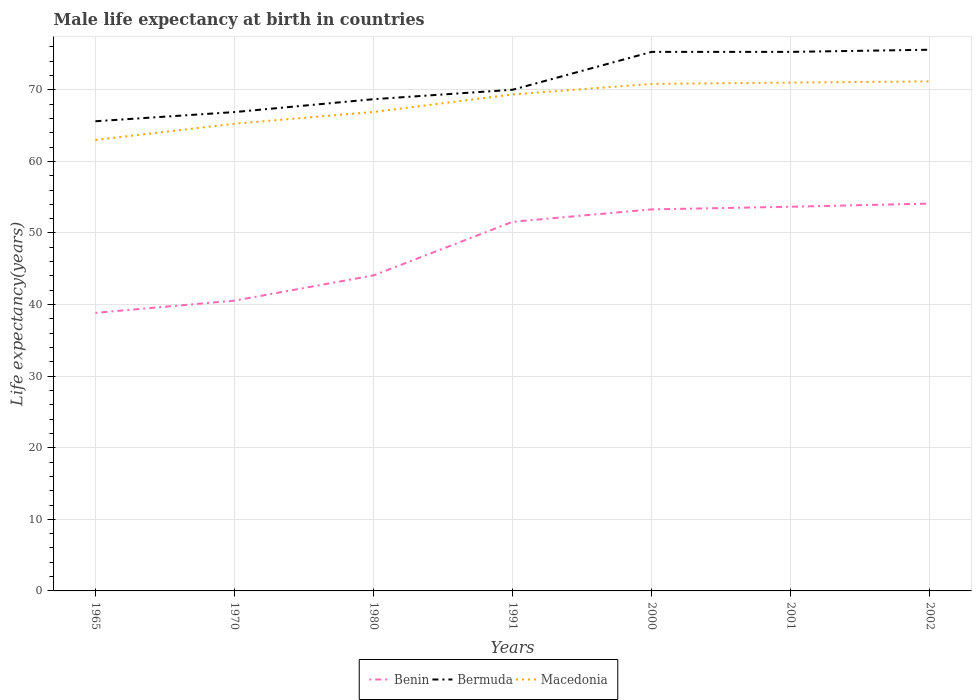How many different coloured lines are there?
Provide a short and direct response. 3. Across all years, what is the maximum male life expectancy at birth in Macedonia?
Your answer should be compact. 63. In which year was the male life expectancy at birth in Macedonia maximum?
Your answer should be compact. 1965. What is the total male life expectancy at birth in Benin in the graph?
Your answer should be compact. -2.1. What is the difference between the highest and the second highest male life expectancy at birth in Macedonia?
Ensure brevity in your answer.  8.18. What is the difference between the highest and the lowest male life expectancy at birth in Benin?
Offer a very short reply. 4. How many lines are there?
Your answer should be very brief. 3. How many years are there in the graph?
Provide a succinct answer. 7. What is the difference between two consecutive major ticks on the Y-axis?
Offer a very short reply. 10. Does the graph contain grids?
Give a very brief answer. Yes. What is the title of the graph?
Provide a succinct answer. Male life expectancy at birth in countries. Does "Zambia" appear as one of the legend labels in the graph?
Your response must be concise. No. What is the label or title of the X-axis?
Offer a terse response. Years. What is the label or title of the Y-axis?
Provide a succinct answer. Life expectancy(years). What is the Life expectancy(years) in Benin in 1965?
Give a very brief answer. 38.84. What is the Life expectancy(years) in Bermuda in 1965?
Provide a succinct answer. 65.61. What is the Life expectancy(years) in Macedonia in 1965?
Keep it short and to the point. 63. What is the Life expectancy(years) in Benin in 1970?
Your answer should be compact. 40.55. What is the Life expectancy(years) of Bermuda in 1970?
Offer a very short reply. 66.89. What is the Life expectancy(years) of Macedonia in 1970?
Offer a very short reply. 65.26. What is the Life expectancy(years) in Benin in 1980?
Your response must be concise. 44.08. What is the Life expectancy(years) of Bermuda in 1980?
Keep it short and to the point. 68.69. What is the Life expectancy(years) of Macedonia in 1980?
Offer a very short reply. 66.91. What is the Life expectancy(years) in Benin in 1991?
Your answer should be compact. 51.56. What is the Life expectancy(years) of Bermuda in 1991?
Your response must be concise. 70.01. What is the Life expectancy(years) in Macedonia in 1991?
Provide a short and direct response. 69.35. What is the Life expectancy(years) of Benin in 2000?
Make the answer very short. 53.3. What is the Life expectancy(years) in Bermuda in 2000?
Provide a short and direct response. 75.3. What is the Life expectancy(years) of Macedonia in 2000?
Provide a short and direct response. 70.83. What is the Life expectancy(years) in Benin in 2001?
Provide a succinct answer. 53.67. What is the Life expectancy(years) of Bermuda in 2001?
Give a very brief answer. 75.3. What is the Life expectancy(years) in Macedonia in 2001?
Give a very brief answer. 71.01. What is the Life expectancy(years) in Benin in 2002?
Your answer should be very brief. 54.11. What is the Life expectancy(years) in Bermuda in 2002?
Offer a very short reply. 75.6. What is the Life expectancy(years) in Macedonia in 2002?
Your answer should be very brief. 71.18. Across all years, what is the maximum Life expectancy(years) of Benin?
Your response must be concise. 54.11. Across all years, what is the maximum Life expectancy(years) of Bermuda?
Provide a succinct answer. 75.6. Across all years, what is the maximum Life expectancy(years) of Macedonia?
Your answer should be very brief. 71.18. Across all years, what is the minimum Life expectancy(years) in Benin?
Provide a succinct answer. 38.84. Across all years, what is the minimum Life expectancy(years) in Bermuda?
Your response must be concise. 65.61. Across all years, what is the minimum Life expectancy(years) of Macedonia?
Offer a very short reply. 63. What is the total Life expectancy(years) in Benin in the graph?
Your response must be concise. 336.11. What is the total Life expectancy(years) of Bermuda in the graph?
Your answer should be compact. 497.4. What is the total Life expectancy(years) of Macedonia in the graph?
Ensure brevity in your answer.  477.54. What is the difference between the Life expectancy(years) of Benin in 1965 and that in 1970?
Offer a terse response. -1.71. What is the difference between the Life expectancy(years) of Bermuda in 1965 and that in 1970?
Your answer should be very brief. -1.28. What is the difference between the Life expectancy(years) in Macedonia in 1965 and that in 1970?
Your response must be concise. -2.26. What is the difference between the Life expectancy(years) of Benin in 1965 and that in 1980?
Your response must be concise. -5.24. What is the difference between the Life expectancy(years) of Bermuda in 1965 and that in 1980?
Provide a succinct answer. -3.08. What is the difference between the Life expectancy(years) in Macedonia in 1965 and that in 1980?
Keep it short and to the point. -3.91. What is the difference between the Life expectancy(years) in Benin in 1965 and that in 1991?
Offer a very short reply. -12.72. What is the difference between the Life expectancy(years) of Macedonia in 1965 and that in 1991?
Provide a succinct answer. -6.35. What is the difference between the Life expectancy(years) of Benin in 1965 and that in 2000?
Make the answer very short. -14.46. What is the difference between the Life expectancy(years) of Bermuda in 1965 and that in 2000?
Provide a succinct answer. -9.69. What is the difference between the Life expectancy(years) in Macedonia in 1965 and that in 2000?
Keep it short and to the point. -7.83. What is the difference between the Life expectancy(years) of Benin in 1965 and that in 2001?
Your answer should be very brief. -14.82. What is the difference between the Life expectancy(years) of Bermuda in 1965 and that in 2001?
Offer a terse response. -9.69. What is the difference between the Life expectancy(years) of Macedonia in 1965 and that in 2001?
Your answer should be compact. -8.01. What is the difference between the Life expectancy(years) of Benin in 1965 and that in 2002?
Make the answer very short. -15.27. What is the difference between the Life expectancy(years) in Bermuda in 1965 and that in 2002?
Ensure brevity in your answer.  -9.99. What is the difference between the Life expectancy(years) of Macedonia in 1965 and that in 2002?
Provide a succinct answer. -8.18. What is the difference between the Life expectancy(years) in Benin in 1970 and that in 1980?
Ensure brevity in your answer.  -3.53. What is the difference between the Life expectancy(years) of Macedonia in 1970 and that in 1980?
Your response must be concise. -1.64. What is the difference between the Life expectancy(years) in Benin in 1970 and that in 1991?
Your answer should be compact. -11.01. What is the difference between the Life expectancy(years) of Bermuda in 1970 and that in 1991?
Make the answer very short. -3.12. What is the difference between the Life expectancy(years) in Macedonia in 1970 and that in 1991?
Give a very brief answer. -4.09. What is the difference between the Life expectancy(years) of Benin in 1970 and that in 2000?
Keep it short and to the point. -12.75. What is the difference between the Life expectancy(years) in Bermuda in 1970 and that in 2000?
Provide a succinct answer. -8.41. What is the difference between the Life expectancy(years) in Macedonia in 1970 and that in 2000?
Give a very brief answer. -5.57. What is the difference between the Life expectancy(years) of Benin in 1970 and that in 2001?
Make the answer very short. -13.12. What is the difference between the Life expectancy(years) in Bermuda in 1970 and that in 2001?
Your answer should be compact. -8.41. What is the difference between the Life expectancy(years) in Macedonia in 1970 and that in 2001?
Ensure brevity in your answer.  -5.74. What is the difference between the Life expectancy(years) of Benin in 1970 and that in 2002?
Keep it short and to the point. -13.56. What is the difference between the Life expectancy(years) of Bermuda in 1970 and that in 2002?
Give a very brief answer. -8.71. What is the difference between the Life expectancy(years) in Macedonia in 1970 and that in 2002?
Give a very brief answer. -5.92. What is the difference between the Life expectancy(years) in Benin in 1980 and that in 1991?
Your response must be concise. -7.49. What is the difference between the Life expectancy(years) of Bermuda in 1980 and that in 1991?
Offer a terse response. -1.32. What is the difference between the Life expectancy(years) of Macedonia in 1980 and that in 1991?
Offer a very short reply. -2.44. What is the difference between the Life expectancy(years) in Benin in 1980 and that in 2000?
Your answer should be compact. -9.22. What is the difference between the Life expectancy(years) of Bermuda in 1980 and that in 2000?
Your answer should be very brief. -6.61. What is the difference between the Life expectancy(years) of Macedonia in 1980 and that in 2000?
Your response must be concise. -3.92. What is the difference between the Life expectancy(years) in Benin in 1980 and that in 2001?
Make the answer very short. -9.59. What is the difference between the Life expectancy(years) of Bermuda in 1980 and that in 2001?
Ensure brevity in your answer.  -6.61. What is the difference between the Life expectancy(years) in Macedonia in 1980 and that in 2001?
Your answer should be compact. -4.1. What is the difference between the Life expectancy(years) in Benin in 1980 and that in 2002?
Ensure brevity in your answer.  -10.03. What is the difference between the Life expectancy(years) in Bermuda in 1980 and that in 2002?
Provide a succinct answer. -6.91. What is the difference between the Life expectancy(years) of Macedonia in 1980 and that in 2002?
Your answer should be very brief. -4.27. What is the difference between the Life expectancy(years) in Benin in 1991 and that in 2000?
Your answer should be very brief. -1.73. What is the difference between the Life expectancy(years) in Bermuda in 1991 and that in 2000?
Offer a terse response. -5.29. What is the difference between the Life expectancy(years) of Macedonia in 1991 and that in 2000?
Your response must be concise. -1.48. What is the difference between the Life expectancy(years) in Benin in 1991 and that in 2001?
Make the answer very short. -2.1. What is the difference between the Life expectancy(years) in Bermuda in 1991 and that in 2001?
Offer a very short reply. -5.29. What is the difference between the Life expectancy(years) of Macedonia in 1991 and that in 2001?
Give a very brief answer. -1.65. What is the difference between the Life expectancy(years) of Benin in 1991 and that in 2002?
Keep it short and to the point. -2.54. What is the difference between the Life expectancy(years) of Bermuda in 1991 and that in 2002?
Your answer should be very brief. -5.59. What is the difference between the Life expectancy(years) in Macedonia in 1991 and that in 2002?
Offer a very short reply. -1.83. What is the difference between the Life expectancy(years) of Benin in 2000 and that in 2001?
Offer a very short reply. -0.37. What is the difference between the Life expectancy(years) in Bermuda in 2000 and that in 2001?
Your answer should be compact. 0. What is the difference between the Life expectancy(years) of Macedonia in 2000 and that in 2001?
Keep it short and to the point. -0.18. What is the difference between the Life expectancy(years) of Benin in 2000 and that in 2002?
Provide a succinct answer. -0.81. What is the difference between the Life expectancy(years) in Bermuda in 2000 and that in 2002?
Ensure brevity in your answer.  -0.3. What is the difference between the Life expectancy(years) of Macedonia in 2000 and that in 2002?
Your response must be concise. -0.35. What is the difference between the Life expectancy(years) in Benin in 2001 and that in 2002?
Provide a succinct answer. -0.44. What is the difference between the Life expectancy(years) of Bermuda in 2001 and that in 2002?
Provide a succinct answer. -0.3. What is the difference between the Life expectancy(years) of Macedonia in 2001 and that in 2002?
Ensure brevity in your answer.  -0.17. What is the difference between the Life expectancy(years) of Benin in 1965 and the Life expectancy(years) of Bermuda in 1970?
Your answer should be compact. -28.05. What is the difference between the Life expectancy(years) in Benin in 1965 and the Life expectancy(years) in Macedonia in 1970?
Your answer should be compact. -26.42. What is the difference between the Life expectancy(years) of Bermuda in 1965 and the Life expectancy(years) of Macedonia in 1970?
Your answer should be very brief. 0.35. What is the difference between the Life expectancy(years) in Benin in 1965 and the Life expectancy(years) in Bermuda in 1980?
Offer a very short reply. -29.85. What is the difference between the Life expectancy(years) in Benin in 1965 and the Life expectancy(years) in Macedonia in 1980?
Provide a succinct answer. -28.07. What is the difference between the Life expectancy(years) in Bermuda in 1965 and the Life expectancy(years) in Macedonia in 1980?
Your answer should be compact. -1.3. What is the difference between the Life expectancy(years) in Benin in 1965 and the Life expectancy(years) in Bermuda in 1991?
Your answer should be compact. -31.17. What is the difference between the Life expectancy(years) in Benin in 1965 and the Life expectancy(years) in Macedonia in 1991?
Offer a terse response. -30.51. What is the difference between the Life expectancy(years) of Bermuda in 1965 and the Life expectancy(years) of Macedonia in 1991?
Offer a very short reply. -3.74. What is the difference between the Life expectancy(years) of Benin in 1965 and the Life expectancy(years) of Bermuda in 2000?
Offer a very short reply. -36.46. What is the difference between the Life expectancy(years) of Benin in 1965 and the Life expectancy(years) of Macedonia in 2000?
Offer a very short reply. -31.99. What is the difference between the Life expectancy(years) in Bermuda in 1965 and the Life expectancy(years) in Macedonia in 2000?
Your response must be concise. -5.22. What is the difference between the Life expectancy(years) in Benin in 1965 and the Life expectancy(years) in Bermuda in 2001?
Ensure brevity in your answer.  -36.46. What is the difference between the Life expectancy(years) in Benin in 1965 and the Life expectancy(years) in Macedonia in 2001?
Provide a short and direct response. -32.16. What is the difference between the Life expectancy(years) in Bermuda in 1965 and the Life expectancy(years) in Macedonia in 2001?
Make the answer very short. -5.4. What is the difference between the Life expectancy(years) in Benin in 1965 and the Life expectancy(years) in Bermuda in 2002?
Offer a terse response. -36.76. What is the difference between the Life expectancy(years) of Benin in 1965 and the Life expectancy(years) of Macedonia in 2002?
Provide a short and direct response. -32.34. What is the difference between the Life expectancy(years) of Bermuda in 1965 and the Life expectancy(years) of Macedonia in 2002?
Your response must be concise. -5.57. What is the difference between the Life expectancy(years) in Benin in 1970 and the Life expectancy(years) in Bermuda in 1980?
Your response must be concise. -28.14. What is the difference between the Life expectancy(years) of Benin in 1970 and the Life expectancy(years) of Macedonia in 1980?
Your response must be concise. -26.36. What is the difference between the Life expectancy(years) in Bermuda in 1970 and the Life expectancy(years) in Macedonia in 1980?
Provide a short and direct response. -0.02. What is the difference between the Life expectancy(years) of Benin in 1970 and the Life expectancy(years) of Bermuda in 1991?
Offer a very short reply. -29.46. What is the difference between the Life expectancy(years) in Benin in 1970 and the Life expectancy(years) in Macedonia in 1991?
Your answer should be compact. -28.8. What is the difference between the Life expectancy(years) in Bermuda in 1970 and the Life expectancy(years) in Macedonia in 1991?
Provide a succinct answer. -2.46. What is the difference between the Life expectancy(years) of Benin in 1970 and the Life expectancy(years) of Bermuda in 2000?
Offer a very short reply. -34.75. What is the difference between the Life expectancy(years) in Benin in 1970 and the Life expectancy(years) in Macedonia in 2000?
Keep it short and to the point. -30.28. What is the difference between the Life expectancy(years) of Bermuda in 1970 and the Life expectancy(years) of Macedonia in 2000?
Give a very brief answer. -3.94. What is the difference between the Life expectancy(years) of Benin in 1970 and the Life expectancy(years) of Bermuda in 2001?
Provide a short and direct response. -34.75. What is the difference between the Life expectancy(years) of Benin in 1970 and the Life expectancy(years) of Macedonia in 2001?
Provide a succinct answer. -30.46. What is the difference between the Life expectancy(years) in Bermuda in 1970 and the Life expectancy(years) in Macedonia in 2001?
Provide a short and direct response. -4.12. What is the difference between the Life expectancy(years) of Benin in 1970 and the Life expectancy(years) of Bermuda in 2002?
Your answer should be compact. -35.05. What is the difference between the Life expectancy(years) of Benin in 1970 and the Life expectancy(years) of Macedonia in 2002?
Keep it short and to the point. -30.63. What is the difference between the Life expectancy(years) in Bermuda in 1970 and the Life expectancy(years) in Macedonia in 2002?
Your response must be concise. -4.29. What is the difference between the Life expectancy(years) in Benin in 1980 and the Life expectancy(years) in Bermuda in 1991?
Your answer should be very brief. -25.93. What is the difference between the Life expectancy(years) of Benin in 1980 and the Life expectancy(years) of Macedonia in 1991?
Offer a very short reply. -25.27. What is the difference between the Life expectancy(years) of Bermuda in 1980 and the Life expectancy(years) of Macedonia in 1991?
Provide a short and direct response. -0.66. What is the difference between the Life expectancy(years) in Benin in 1980 and the Life expectancy(years) in Bermuda in 2000?
Your answer should be very brief. -31.22. What is the difference between the Life expectancy(years) in Benin in 1980 and the Life expectancy(years) in Macedonia in 2000?
Provide a succinct answer. -26.75. What is the difference between the Life expectancy(years) of Bermuda in 1980 and the Life expectancy(years) of Macedonia in 2000?
Your answer should be very brief. -2.14. What is the difference between the Life expectancy(years) of Benin in 1980 and the Life expectancy(years) of Bermuda in 2001?
Provide a short and direct response. -31.22. What is the difference between the Life expectancy(years) of Benin in 1980 and the Life expectancy(years) of Macedonia in 2001?
Give a very brief answer. -26.93. What is the difference between the Life expectancy(years) of Bermuda in 1980 and the Life expectancy(years) of Macedonia in 2001?
Ensure brevity in your answer.  -2.32. What is the difference between the Life expectancy(years) in Benin in 1980 and the Life expectancy(years) in Bermuda in 2002?
Give a very brief answer. -31.52. What is the difference between the Life expectancy(years) of Benin in 1980 and the Life expectancy(years) of Macedonia in 2002?
Ensure brevity in your answer.  -27.1. What is the difference between the Life expectancy(years) of Bermuda in 1980 and the Life expectancy(years) of Macedonia in 2002?
Your answer should be compact. -2.49. What is the difference between the Life expectancy(years) of Benin in 1991 and the Life expectancy(years) of Bermuda in 2000?
Ensure brevity in your answer.  -23.74. What is the difference between the Life expectancy(years) in Benin in 1991 and the Life expectancy(years) in Macedonia in 2000?
Make the answer very short. -19.27. What is the difference between the Life expectancy(years) in Bermuda in 1991 and the Life expectancy(years) in Macedonia in 2000?
Make the answer very short. -0.82. What is the difference between the Life expectancy(years) of Benin in 1991 and the Life expectancy(years) of Bermuda in 2001?
Make the answer very short. -23.74. What is the difference between the Life expectancy(years) in Benin in 1991 and the Life expectancy(years) in Macedonia in 2001?
Ensure brevity in your answer.  -19.44. What is the difference between the Life expectancy(years) of Bermuda in 1991 and the Life expectancy(years) of Macedonia in 2001?
Give a very brief answer. -1. What is the difference between the Life expectancy(years) in Benin in 1991 and the Life expectancy(years) in Bermuda in 2002?
Your response must be concise. -24.04. What is the difference between the Life expectancy(years) in Benin in 1991 and the Life expectancy(years) in Macedonia in 2002?
Offer a terse response. -19.62. What is the difference between the Life expectancy(years) of Bermuda in 1991 and the Life expectancy(years) of Macedonia in 2002?
Give a very brief answer. -1.17. What is the difference between the Life expectancy(years) in Benin in 2000 and the Life expectancy(years) in Bermuda in 2001?
Provide a succinct answer. -22. What is the difference between the Life expectancy(years) in Benin in 2000 and the Life expectancy(years) in Macedonia in 2001?
Keep it short and to the point. -17.71. What is the difference between the Life expectancy(years) in Bermuda in 2000 and the Life expectancy(years) in Macedonia in 2001?
Offer a terse response. 4.29. What is the difference between the Life expectancy(years) of Benin in 2000 and the Life expectancy(years) of Bermuda in 2002?
Your answer should be compact. -22.3. What is the difference between the Life expectancy(years) of Benin in 2000 and the Life expectancy(years) of Macedonia in 2002?
Your answer should be very brief. -17.88. What is the difference between the Life expectancy(years) of Bermuda in 2000 and the Life expectancy(years) of Macedonia in 2002?
Your response must be concise. 4.12. What is the difference between the Life expectancy(years) in Benin in 2001 and the Life expectancy(years) in Bermuda in 2002?
Your response must be concise. -21.93. What is the difference between the Life expectancy(years) of Benin in 2001 and the Life expectancy(years) of Macedonia in 2002?
Offer a very short reply. -17.52. What is the difference between the Life expectancy(years) in Bermuda in 2001 and the Life expectancy(years) in Macedonia in 2002?
Your answer should be compact. 4.12. What is the average Life expectancy(years) in Benin per year?
Provide a succinct answer. 48.02. What is the average Life expectancy(years) of Bermuda per year?
Provide a short and direct response. 71.06. What is the average Life expectancy(years) of Macedonia per year?
Ensure brevity in your answer.  68.22. In the year 1965, what is the difference between the Life expectancy(years) in Benin and Life expectancy(years) in Bermuda?
Your response must be concise. -26.77. In the year 1965, what is the difference between the Life expectancy(years) in Benin and Life expectancy(years) in Macedonia?
Provide a succinct answer. -24.16. In the year 1965, what is the difference between the Life expectancy(years) of Bermuda and Life expectancy(years) of Macedonia?
Keep it short and to the point. 2.61. In the year 1970, what is the difference between the Life expectancy(years) of Benin and Life expectancy(years) of Bermuda?
Make the answer very short. -26.34. In the year 1970, what is the difference between the Life expectancy(years) of Benin and Life expectancy(years) of Macedonia?
Your answer should be compact. -24.71. In the year 1970, what is the difference between the Life expectancy(years) of Bermuda and Life expectancy(years) of Macedonia?
Offer a terse response. 1.63. In the year 1980, what is the difference between the Life expectancy(years) in Benin and Life expectancy(years) in Bermuda?
Keep it short and to the point. -24.61. In the year 1980, what is the difference between the Life expectancy(years) of Benin and Life expectancy(years) of Macedonia?
Your answer should be compact. -22.83. In the year 1980, what is the difference between the Life expectancy(years) in Bermuda and Life expectancy(years) in Macedonia?
Offer a terse response. 1.78. In the year 1991, what is the difference between the Life expectancy(years) in Benin and Life expectancy(years) in Bermuda?
Keep it short and to the point. -18.45. In the year 1991, what is the difference between the Life expectancy(years) of Benin and Life expectancy(years) of Macedonia?
Give a very brief answer. -17.79. In the year 1991, what is the difference between the Life expectancy(years) of Bermuda and Life expectancy(years) of Macedonia?
Ensure brevity in your answer.  0.66. In the year 2000, what is the difference between the Life expectancy(years) in Benin and Life expectancy(years) in Bermuda?
Your answer should be very brief. -22. In the year 2000, what is the difference between the Life expectancy(years) of Benin and Life expectancy(years) of Macedonia?
Give a very brief answer. -17.53. In the year 2000, what is the difference between the Life expectancy(years) in Bermuda and Life expectancy(years) in Macedonia?
Your answer should be very brief. 4.47. In the year 2001, what is the difference between the Life expectancy(years) in Benin and Life expectancy(years) in Bermuda?
Your response must be concise. -21.63. In the year 2001, what is the difference between the Life expectancy(years) in Benin and Life expectancy(years) in Macedonia?
Give a very brief answer. -17.34. In the year 2001, what is the difference between the Life expectancy(years) in Bermuda and Life expectancy(years) in Macedonia?
Provide a succinct answer. 4.29. In the year 2002, what is the difference between the Life expectancy(years) in Benin and Life expectancy(years) in Bermuda?
Provide a short and direct response. -21.49. In the year 2002, what is the difference between the Life expectancy(years) of Benin and Life expectancy(years) of Macedonia?
Your response must be concise. -17.07. In the year 2002, what is the difference between the Life expectancy(years) in Bermuda and Life expectancy(years) in Macedonia?
Provide a short and direct response. 4.42. What is the ratio of the Life expectancy(years) in Benin in 1965 to that in 1970?
Provide a short and direct response. 0.96. What is the ratio of the Life expectancy(years) in Bermuda in 1965 to that in 1970?
Your response must be concise. 0.98. What is the ratio of the Life expectancy(years) of Macedonia in 1965 to that in 1970?
Make the answer very short. 0.97. What is the ratio of the Life expectancy(years) of Benin in 1965 to that in 1980?
Ensure brevity in your answer.  0.88. What is the ratio of the Life expectancy(years) in Bermuda in 1965 to that in 1980?
Provide a succinct answer. 0.96. What is the ratio of the Life expectancy(years) in Macedonia in 1965 to that in 1980?
Ensure brevity in your answer.  0.94. What is the ratio of the Life expectancy(years) in Benin in 1965 to that in 1991?
Give a very brief answer. 0.75. What is the ratio of the Life expectancy(years) of Bermuda in 1965 to that in 1991?
Your answer should be very brief. 0.94. What is the ratio of the Life expectancy(years) of Macedonia in 1965 to that in 1991?
Give a very brief answer. 0.91. What is the ratio of the Life expectancy(years) of Benin in 1965 to that in 2000?
Give a very brief answer. 0.73. What is the ratio of the Life expectancy(years) of Bermuda in 1965 to that in 2000?
Your response must be concise. 0.87. What is the ratio of the Life expectancy(years) of Macedonia in 1965 to that in 2000?
Your answer should be compact. 0.89. What is the ratio of the Life expectancy(years) in Benin in 1965 to that in 2001?
Ensure brevity in your answer.  0.72. What is the ratio of the Life expectancy(years) of Bermuda in 1965 to that in 2001?
Ensure brevity in your answer.  0.87. What is the ratio of the Life expectancy(years) in Macedonia in 1965 to that in 2001?
Provide a succinct answer. 0.89. What is the ratio of the Life expectancy(years) in Benin in 1965 to that in 2002?
Ensure brevity in your answer.  0.72. What is the ratio of the Life expectancy(years) of Bermuda in 1965 to that in 2002?
Ensure brevity in your answer.  0.87. What is the ratio of the Life expectancy(years) in Macedonia in 1965 to that in 2002?
Provide a succinct answer. 0.89. What is the ratio of the Life expectancy(years) of Bermuda in 1970 to that in 1980?
Your answer should be very brief. 0.97. What is the ratio of the Life expectancy(years) in Macedonia in 1970 to that in 1980?
Provide a short and direct response. 0.98. What is the ratio of the Life expectancy(years) in Benin in 1970 to that in 1991?
Give a very brief answer. 0.79. What is the ratio of the Life expectancy(years) in Bermuda in 1970 to that in 1991?
Offer a very short reply. 0.96. What is the ratio of the Life expectancy(years) in Macedonia in 1970 to that in 1991?
Your answer should be very brief. 0.94. What is the ratio of the Life expectancy(years) in Benin in 1970 to that in 2000?
Provide a succinct answer. 0.76. What is the ratio of the Life expectancy(years) of Bermuda in 1970 to that in 2000?
Give a very brief answer. 0.89. What is the ratio of the Life expectancy(years) of Macedonia in 1970 to that in 2000?
Provide a short and direct response. 0.92. What is the ratio of the Life expectancy(years) in Benin in 1970 to that in 2001?
Provide a succinct answer. 0.76. What is the ratio of the Life expectancy(years) in Bermuda in 1970 to that in 2001?
Keep it short and to the point. 0.89. What is the ratio of the Life expectancy(years) in Macedonia in 1970 to that in 2001?
Give a very brief answer. 0.92. What is the ratio of the Life expectancy(years) in Benin in 1970 to that in 2002?
Keep it short and to the point. 0.75. What is the ratio of the Life expectancy(years) of Bermuda in 1970 to that in 2002?
Your response must be concise. 0.88. What is the ratio of the Life expectancy(years) in Macedonia in 1970 to that in 2002?
Provide a succinct answer. 0.92. What is the ratio of the Life expectancy(years) in Benin in 1980 to that in 1991?
Keep it short and to the point. 0.85. What is the ratio of the Life expectancy(years) in Bermuda in 1980 to that in 1991?
Provide a short and direct response. 0.98. What is the ratio of the Life expectancy(years) of Macedonia in 1980 to that in 1991?
Provide a succinct answer. 0.96. What is the ratio of the Life expectancy(years) in Benin in 1980 to that in 2000?
Offer a terse response. 0.83. What is the ratio of the Life expectancy(years) of Bermuda in 1980 to that in 2000?
Your answer should be very brief. 0.91. What is the ratio of the Life expectancy(years) of Macedonia in 1980 to that in 2000?
Your answer should be compact. 0.94. What is the ratio of the Life expectancy(years) in Benin in 1980 to that in 2001?
Provide a short and direct response. 0.82. What is the ratio of the Life expectancy(years) in Bermuda in 1980 to that in 2001?
Make the answer very short. 0.91. What is the ratio of the Life expectancy(years) of Macedonia in 1980 to that in 2001?
Your response must be concise. 0.94. What is the ratio of the Life expectancy(years) in Benin in 1980 to that in 2002?
Your answer should be compact. 0.81. What is the ratio of the Life expectancy(years) in Bermuda in 1980 to that in 2002?
Provide a short and direct response. 0.91. What is the ratio of the Life expectancy(years) in Macedonia in 1980 to that in 2002?
Make the answer very short. 0.94. What is the ratio of the Life expectancy(years) in Benin in 1991 to that in 2000?
Offer a very short reply. 0.97. What is the ratio of the Life expectancy(years) in Bermuda in 1991 to that in 2000?
Ensure brevity in your answer.  0.93. What is the ratio of the Life expectancy(years) of Macedonia in 1991 to that in 2000?
Keep it short and to the point. 0.98. What is the ratio of the Life expectancy(years) in Benin in 1991 to that in 2001?
Your answer should be very brief. 0.96. What is the ratio of the Life expectancy(years) of Bermuda in 1991 to that in 2001?
Your response must be concise. 0.93. What is the ratio of the Life expectancy(years) of Macedonia in 1991 to that in 2001?
Ensure brevity in your answer.  0.98. What is the ratio of the Life expectancy(years) of Benin in 1991 to that in 2002?
Ensure brevity in your answer.  0.95. What is the ratio of the Life expectancy(years) in Bermuda in 1991 to that in 2002?
Your answer should be compact. 0.93. What is the ratio of the Life expectancy(years) in Macedonia in 1991 to that in 2002?
Ensure brevity in your answer.  0.97. What is the ratio of the Life expectancy(years) in Macedonia in 2000 to that in 2001?
Make the answer very short. 1. What is the ratio of the Life expectancy(years) of Benin in 2000 to that in 2002?
Your answer should be compact. 0.98. What is the ratio of the Life expectancy(years) of Bermuda in 2000 to that in 2002?
Keep it short and to the point. 1. What is the ratio of the Life expectancy(years) of Macedonia in 2000 to that in 2002?
Ensure brevity in your answer.  1. What is the ratio of the Life expectancy(years) of Benin in 2001 to that in 2002?
Your response must be concise. 0.99. What is the ratio of the Life expectancy(years) in Bermuda in 2001 to that in 2002?
Your response must be concise. 1. What is the ratio of the Life expectancy(years) in Macedonia in 2001 to that in 2002?
Your response must be concise. 1. What is the difference between the highest and the second highest Life expectancy(years) in Benin?
Your response must be concise. 0.44. What is the difference between the highest and the second highest Life expectancy(years) in Macedonia?
Offer a very short reply. 0.17. What is the difference between the highest and the lowest Life expectancy(years) in Benin?
Provide a succinct answer. 15.27. What is the difference between the highest and the lowest Life expectancy(years) in Bermuda?
Your answer should be very brief. 9.99. What is the difference between the highest and the lowest Life expectancy(years) in Macedonia?
Provide a succinct answer. 8.18. 